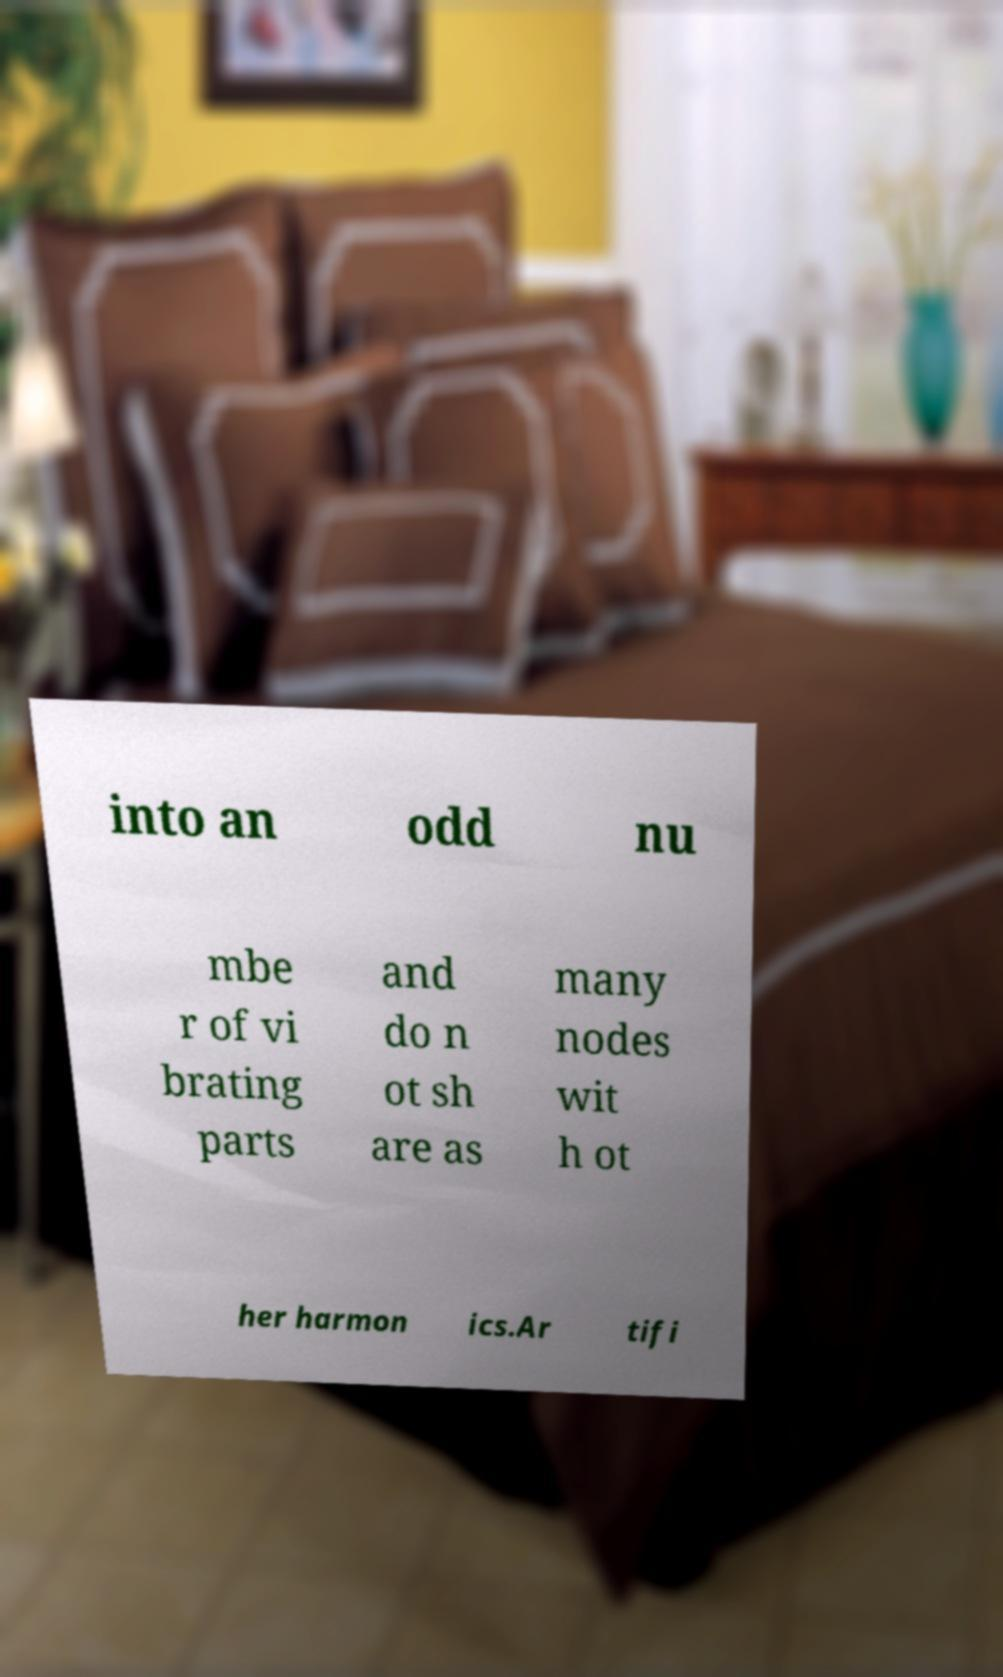There's text embedded in this image that I need extracted. Can you transcribe it verbatim? into an odd nu mbe r of vi brating parts and do n ot sh are as many nodes wit h ot her harmon ics.Ar tifi 